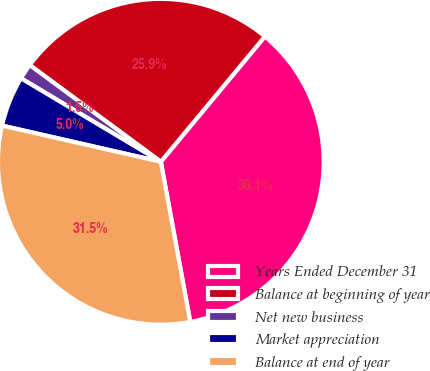Convert chart. <chart><loc_0><loc_0><loc_500><loc_500><pie_chart><fcel>Years Ended December 31<fcel>Balance at beginning of year<fcel>Net new business<fcel>Market appreciation<fcel>Balance at end of year<nl><fcel>36.08%<fcel>25.92%<fcel>1.55%<fcel>5.0%<fcel>31.46%<nl></chart> 